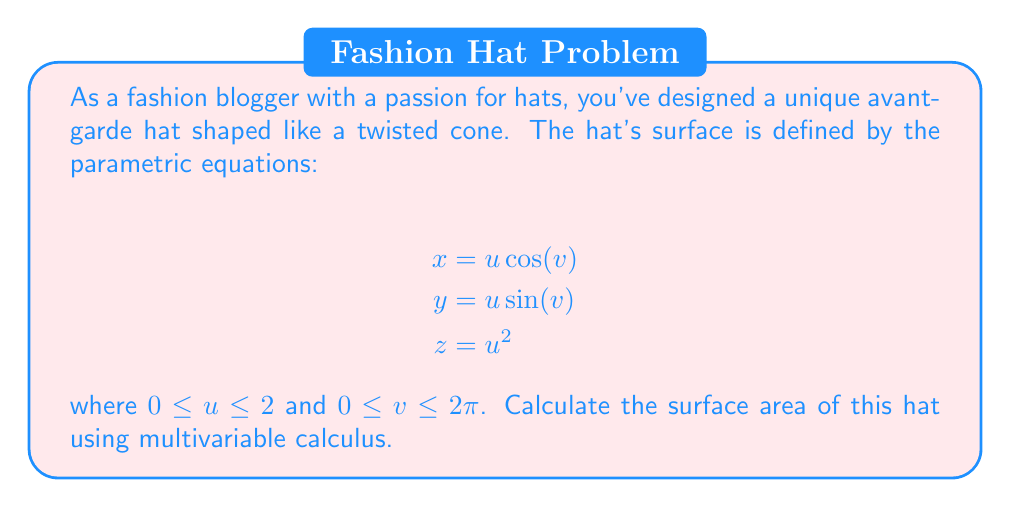Solve this math problem. To calculate the surface area of the hat, we need to use the surface integral formula:

$$\text{Surface Area} = \iint_S \sqrt{EG - F^2} \, du \, dv$$

where $E$, $F$, and $G$ are the coefficients of the first fundamental form.

Step 1: Calculate the partial derivatives
$$\frac{\partial x}{\partial u} = \cos(v), \quad \frac{\partial x}{\partial v} = -u \sin(v)$$
$$\frac{\partial y}{\partial u} = \sin(v), \quad \frac{\partial y}{\partial v} = u \cos(v)$$
$$\frac{\partial z}{\partial u} = 2u, \quad \frac{\partial z}{\partial v} = 0$$

Step 2: Calculate $E$, $F$, and $G$
$$E = \left(\frac{\partial x}{\partial u}\right)^2 + \left(\frac{\partial y}{\partial u}\right)^2 + \left(\frac{\partial z}{\partial u}\right)^2 = \cos^2(v) + \sin^2(v) + 4u^2 = 1 + 4u^2$$

$$F = \frac{\partial x}{\partial u}\frac{\partial x}{\partial v} + \frac{\partial y}{\partial u}\frac{\partial y}{\partial v} + \frac{\partial z}{\partial u}\frac{\partial z}{\partial v} = -u\sin(v)\cos(v) + u\sin(v)\cos(v) + 0 = 0$$

$$G = \left(\frac{\partial x}{\partial v}\right)^2 + \left(\frac{\partial y}{\partial v}\right)^2 + \left(\frac{\partial z}{\partial v}\right)^2 = u^2\sin^2(v) + u^2\cos^2(v) + 0 = u^2$$

Step 3: Calculate $\sqrt{EG - F^2}$
$$\sqrt{EG - F^2} = \sqrt{(1 + 4u^2)(u^2) - 0^2} = u\sqrt{1 + 4u^2}$$

Step 4: Set up and evaluate the double integral
$$\text{Surface Area} = \int_0^{2\pi} \int_0^2 u\sqrt{1 + 4u^2} \, du \, dv$$

$$= 2\pi \int_0^2 u\sqrt{1 + 4u^2} \, du$$

Step 5: Solve the integral using substitution
Let $w = 1 + 4u^2$, then $dw = 8u \, du$ and $u \, du = \frac{1}{8} \, dw$

$$= \frac{\pi}{4} \int_1^{17} \sqrt{w} \, dw$$

$$= \frac{\pi}{4} \left[\frac{2}{3}w^{3/2}\right]_1^{17}$$

$$= \frac{\pi}{6} \left(17^{3/2} - 1\right)$$

$$\approx 36.07 \text{ square units}$$
Answer: $\frac{\pi}{6}(17^{3/2} - 1)$ square units 